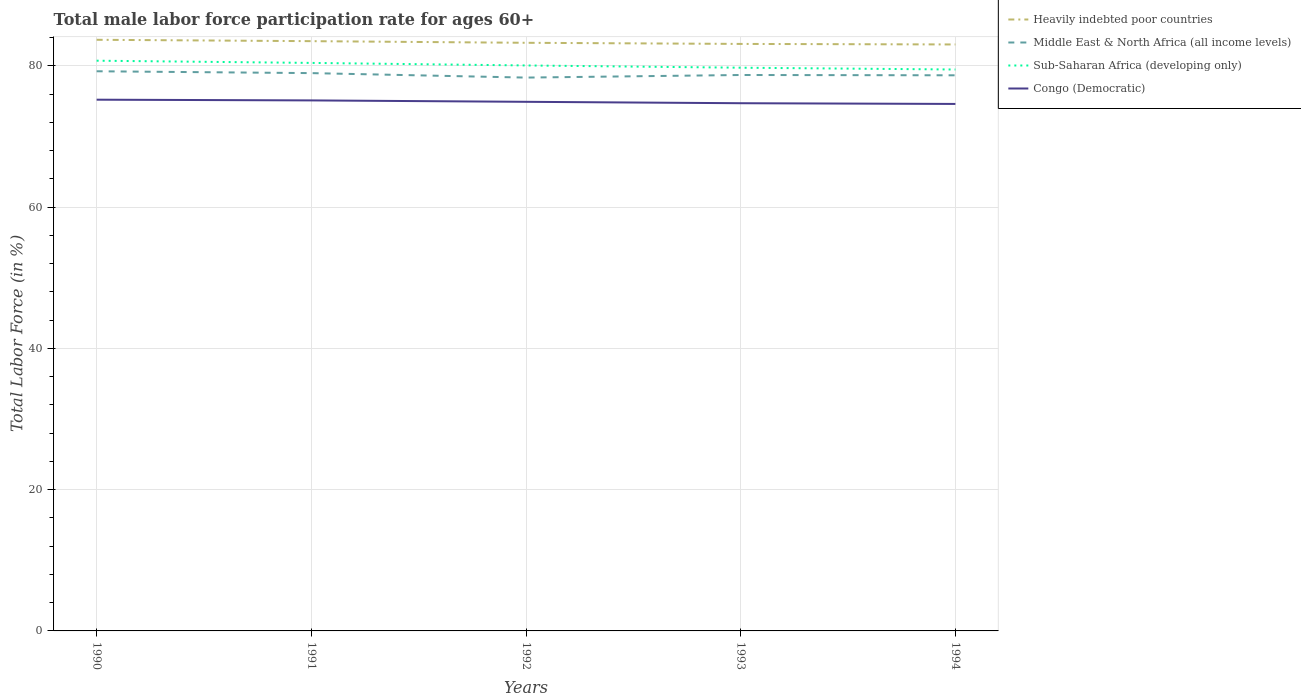How many different coloured lines are there?
Ensure brevity in your answer.  4. Does the line corresponding to Middle East & North Africa (all income levels) intersect with the line corresponding to Heavily indebted poor countries?
Your answer should be compact. No. Across all years, what is the maximum male labor force participation rate in Middle East & North Africa (all income levels)?
Offer a terse response. 78.33. In which year was the male labor force participation rate in Sub-Saharan Africa (developing only) maximum?
Offer a very short reply. 1994. What is the total male labor force participation rate in Congo (Democratic) in the graph?
Ensure brevity in your answer.  0.2. What is the difference between the highest and the second highest male labor force participation rate in Heavily indebted poor countries?
Keep it short and to the point. 0.66. What is the difference between the highest and the lowest male labor force participation rate in Heavily indebted poor countries?
Ensure brevity in your answer.  2. Is the male labor force participation rate in Middle East & North Africa (all income levels) strictly greater than the male labor force participation rate in Congo (Democratic) over the years?
Your response must be concise. No. Are the values on the major ticks of Y-axis written in scientific E-notation?
Keep it short and to the point. No. How are the legend labels stacked?
Provide a succinct answer. Vertical. What is the title of the graph?
Provide a succinct answer. Total male labor force participation rate for ages 60+. Does "Cabo Verde" appear as one of the legend labels in the graph?
Provide a short and direct response. No. What is the label or title of the X-axis?
Give a very brief answer. Years. What is the Total Labor Force (in %) in Heavily indebted poor countries in 1990?
Give a very brief answer. 83.68. What is the Total Labor Force (in %) of Middle East & North Africa (all income levels) in 1990?
Keep it short and to the point. 79.22. What is the Total Labor Force (in %) in Sub-Saharan Africa (developing only) in 1990?
Provide a succinct answer. 80.72. What is the Total Labor Force (in %) in Congo (Democratic) in 1990?
Your response must be concise. 75.2. What is the Total Labor Force (in %) of Heavily indebted poor countries in 1991?
Provide a short and direct response. 83.49. What is the Total Labor Force (in %) in Middle East & North Africa (all income levels) in 1991?
Ensure brevity in your answer.  78.96. What is the Total Labor Force (in %) of Sub-Saharan Africa (developing only) in 1991?
Your answer should be compact. 80.41. What is the Total Labor Force (in %) of Congo (Democratic) in 1991?
Provide a succinct answer. 75.1. What is the Total Labor Force (in %) in Heavily indebted poor countries in 1992?
Your answer should be very brief. 83.25. What is the Total Labor Force (in %) in Middle East & North Africa (all income levels) in 1992?
Offer a very short reply. 78.33. What is the Total Labor Force (in %) of Sub-Saharan Africa (developing only) in 1992?
Your answer should be compact. 80.05. What is the Total Labor Force (in %) in Congo (Democratic) in 1992?
Offer a very short reply. 74.9. What is the Total Labor Force (in %) in Heavily indebted poor countries in 1993?
Your answer should be very brief. 83.09. What is the Total Labor Force (in %) in Middle East & North Africa (all income levels) in 1993?
Your response must be concise. 78.7. What is the Total Labor Force (in %) in Sub-Saharan Africa (developing only) in 1993?
Keep it short and to the point. 79.73. What is the Total Labor Force (in %) in Congo (Democratic) in 1993?
Offer a terse response. 74.7. What is the Total Labor Force (in %) in Heavily indebted poor countries in 1994?
Offer a terse response. 83.02. What is the Total Labor Force (in %) of Middle East & North Africa (all income levels) in 1994?
Your response must be concise. 78.65. What is the Total Labor Force (in %) in Sub-Saharan Africa (developing only) in 1994?
Offer a very short reply. 79.47. What is the Total Labor Force (in %) of Congo (Democratic) in 1994?
Provide a short and direct response. 74.6. Across all years, what is the maximum Total Labor Force (in %) of Heavily indebted poor countries?
Ensure brevity in your answer.  83.68. Across all years, what is the maximum Total Labor Force (in %) of Middle East & North Africa (all income levels)?
Provide a succinct answer. 79.22. Across all years, what is the maximum Total Labor Force (in %) of Sub-Saharan Africa (developing only)?
Offer a terse response. 80.72. Across all years, what is the maximum Total Labor Force (in %) of Congo (Democratic)?
Your answer should be compact. 75.2. Across all years, what is the minimum Total Labor Force (in %) in Heavily indebted poor countries?
Provide a succinct answer. 83.02. Across all years, what is the minimum Total Labor Force (in %) in Middle East & North Africa (all income levels)?
Your response must be concise. 78.33. Across all years, what is the minimum Total Labor Force (in %) in Sub-Saharan Africa (developing only)?
Offer a terse response. 79.47. Across all years, what is the minimum Total Labor Force (in %) of Congo (Democratic)?
Your response must be concise. 74.6. What is the total Total Labor Force (in %) in Heavily indebted poor countries in the graph?
Your response must be concise. 416.53. What is the total Total Labor Force (in %) in Middle East & North Africa (all income levels) in the graph?
Give a very brief answer. 393.87. What is the total Total Labor Force (in %) in Sub-Saharan Africa (developing only) in the graph?
Offer a very short reply. 400.37. What is the total Total Labor Force (in %) in Congo (Democratic) in the graph?
Provide a succinct answer. 374.5. What is the difference between the Total Labor Force (in %) of Heavily indebted poor countries in 1990 and that in 1991?
Give a very brief answer. 0.19. What is the difference between the Total Labor Force (in %) of Middle East & North Africa (all income levels) in 1990 and that in 1991?
Keep it short and to the point. 0.26. What is the difference between the Total Labor Force (in %) of Sub-Saharan Africa (developing only) in 1990 and that in 1991?
Provide a short and direct response. 0.31. What is the difference between the Total Labor Force (in %) in Congo (Democratic) in 1990 and that in 1991?
Provide a short and direct response. 0.1. What is the difference between the Total Labor Force (in %) of Heavily indebted poor countries in 1990 and that in 1992?
Offer a very short reply. 0.43. What is the difference between the Total Labor Force (in %) of Middle East & North Africa (all income levels) in 1990 and that in 1992?
Provide a succinct answer. 0.89. What is the difference between the Total Labor Force (in %) in Sub-Saharan Africa (developing only) in 1990 and that in 1992?
Keep it short and to the point. 0.67. What is the difference between the Total Labor Force (in %) in Congo (Democratic) in 1990 and that in 1992?
Keep it short and to the point. 0.3. What is the difference between the Total Labor Force (in %) in Heavily indebted poor countries in 1990 and that in 1993?
Your answer should be very brief. 0.59. What is the difference between the Total Labor Force (in %) of Middle East & North Africa (all income levels) in 1990 and that in 1993?
Offer a very short reply. 0.53. What is the difference between the Total Labor Force (in %) in Sub-Saharan Africa (developing only) in 1990 and that in 1993?
Offer a very short reply. 0.99. What is the difference between the Total Labor Force (in %) in Congo (Democratic) in 1990 and that in 1993?
Your response must be concise. 0.5. What is the difference between the Total Labor Force (in %) of Heavily indebted poor countries in 1990 and that in 1994?
Your response must be concise. 0.66. What is the difference between the Total Labor Force (in %) of Middle East & North Africa (all income levels) in 1990 and that in 1994?
Make the answer very short. 0.57. What is the difference between the Total Labor Force (in %) in Sub-Saharan Africa (developing only) in 1990 and that in 1994?
Ensure brevity in your answer.  1.25. What is the difference between the Total Labor Force (in %) of Congo (Democratic) in 1990 and that in 1994?
Make the answer very short. 0.6. What is the difference between the Total Labor Force (in %) in Heavily indebted poor countries in 1991 and that in 1992?
Your answer should be very brief. 0.23. What is the difference between the Total Labor Force (in %) of Middle East & North Africa (all income levels) in 1991 and that in 1992?
Your answer should be compact. 0.63. What is the difference between the Total Labor Force (in %) in Sub-Saharan Africa (developing only) in 1991 and that in 1992?
Provide a short and direct response. 0.36. What is the difference between the Total Labor Force (in %) in Congo (Democratic) in 1991 and that in 1992?
Keep it short and to the point. 0.2. What is the difference between the Total Labor Force (in %) in Heavily indebted poor countries in 1991 and that in 1993?
Provide a succinct answer. 0.39. What is the difference between the Total Labor Force (in %) in Middle East & North Africa (all income levels) in 1991 and that in 1993?
Provide a succinct answer. 0.27. What is the difference between the Total Labor Force (in %) in Sub-Saharan Africa (developing only) in 1991 and that in 1993?
Keep it short and to the point. 0.68. What is the difference between the Total Labor Force (in %) of Congo (Democratic) in 1991 and that in 1993?
Ensure brevity in your answer.  0.4. What is the difference between the Total Labor Force (in %) of Heavily indebted poor countries in 1991 and that in 1994?
Make the answer very short. 0.47. What is the difference between the Total Labor Force (in %) of Middle East & North Africa (all income levels) in 1991 and that in 1994?
Ensure brevity in your answer.  0.31. What is the difference between the Total Labor Force (in %) of Sub-Saharan Africa (developing only) in 1991 and that in 1994?
Your response must be concise. 0.93. What is the difference between the Total Labor Force (in %) of Heavily indebted poor countries in 1992 and that in 1993?
Keep it short and to the point. 0.16. What is the difference between the Total Labor Force (in %) in Middle East & North Africa (all income levels) in 1992 and that in 1993?
Your response must be concise. -0.37. What is the difference between the Total Labor Force (in %) in Sub-Saharan Africa (developing only) in 1992 and that in 1993?
Your answer should be compact. 0.32. What is the difference between the Total Labor Force (in %) of Heavily indebted poor countries in 1992 and that in 1994?
Your answer should be compact. 0.24. What is the difference between the Total Labor Force (in %) of Middle East & North Africa (all income levels) in 1992 and that in 1994?
Make the answer very short. -0.32. What is the difference between the Total Labor Force (in %) of Sub-Saharan Africa (developing only) in 1992 and that in 1994?
Offer a very short reply. 0.58. What is the difference between the Total Labor Force (in %) of Congo (Democratic) in 1992 and that in 1994?
Ensure brevity in your answer.  0.3. What is the difference between the Total Labor Force (in %) in Heavily indebted poor countries in 1993 and that in 1994?
Your response must be concise. 0.08. What is the difference between the Total Labor Force (in %) in Middle East & North Africa (all income levels) in 1993 and that in 1994?
Offer a terse response. 0.04. What is the difference between the Total Labor Force (in %) in Sub-Saharan Africa (developing only) in 1993 and that in 1994?
Keep it short and to the point. 0.26. What is the difference between the Total Labor Force (in %) of Heavily indebted poor countries in 1990 and the Total Labor Force (in %) of Middle East & North Africa (all income levels) in 1991?
Keep it short and to the point. 4.72. What is the difference between the Total Labor Force (in %) in Heavily indebted poor countries in 1990 and the Total Labor Force (in %) in Sub-Saharan Africa (developing only) in 1991?
Offer a terse response. 3.27. What is the difference between the Total Labor Force (in %) in Heavily indebted poor countries in 1990 and the Total Labor Force (in %) in Congo (Democratic) in 1991?
Give a very brief answer. 8.58. What is the difference between the Total Labor Force (in %) in Middle East & North Africa (all income levels) in 1990 and the Total Labor Force (in %) in Sub-Saharan Africa (developing only) in 1991?
Give a very brief answer. -1.18. What is the difference between the Total Labor Force (in %) in Middle East & North Africa (all income levels) in 1990 and the Total Labor Force (in %) in Congo (Democratic) in 1991?
Offer a very short reply. 4.12. What is the difference between the Total Labor Force (in %) in Sub-Saharan Africa (developing only) in 1990 and the Total Labor Force (in %) in Congo (Democratic) in 1991?
Offer a terse response. 5.62. What is the difference between the Total Labor Force (in %) of Heavily indebted poor countries in 1990 and the Total Labor Force (in %) of Middle East & North Africa (all income levels) in 1992?
Your answer should be compact. 5.35. What is the difference between the Total Labor Force (in %) in Heavily indebted poor countries in 1990 and the Total Labor Force (in %) in Sub-Saharan Africa (developing only) in 1992?
Provide a short and direct response. 3.63. What is the difference between the Total Labor Force (in %) in Heavily indebted poor countries in 1990 and the Total Labor Force (in %) in Congo (Democratic) in 1992?
Your answer should be compact. 8.78. What is the difference between the Total Labor Force (in %) of Middle East & North Africa (all income levels) in 1990 and the Total Labor Force (in %) of Sub-Saharan Africa (developing only) in 1992?
Ensure brevity in your answer.  -0.82. What is the difference between the Total Labor Force (in %) in Middle East & North Africa (all income levels) in 1990 and the Total Labor Force (in %) in Congo (Democratic) in 1992?
Provide a short and direct response. 4.32. What is the difference between the Total Labor Force (in %) in Sub-Saharan Africa (developing only) in 1990 and the Total Labor Force (in %) in Congo (Democratic) in 1992?
Provide a succinct answer. 5.82. What is the difference between the Total Labor Force (in %) of Heavily indebted poor countries in 1990 and the Total Labor Force (in %) of Middle East & North Africa (all income levels) in 1993?
Give a very brief answer. 4.98. What is the difference between the Total Labor Force (in %) in Heavily indebted poor countries in 1990 and the Total Labor Force (in %) in Sub-Saharan Africa (developing only) in 1993?
Offer a terse response. 3.95. What is the difference between the Total Labor Force (in %) of Heavily indebted poor countries in 1990 and the Total Labor Force (in %) of Congo (Democratic) in 1993?
Provide a short and direct response. 8.98. What is the difference between the Total Labor Force (in %) in Middle East & North Africa (all income levels) in 1990 and the Total Labor Force (in %) in Sub-Saharan Africa (developing only) in 1993?
Your answer should be very brief. -0.5. What is the difference between the Total Labor Force (in %) of Middle East & North Africa (all income levels) in 1990 and the Total Labor Force (in %) of Congo (Democratic) in 1993?
Your response must be concise. 4.52. What is the difference between the Total Labor Force (in %) in Sub-Saharan Africa (developing only) in 1990 and the Total Labor Force (in %) in Congo (Democratic) in 1993?
Ensure brevity in your answer.  6.02. What is the difference between the Total Labor Force (in %) of Heavily indebted poor countries in 1990 and the Total Labor Force (in %) of Middle East & North Africa (all income levels) in 1994?
Offer a very short reply. 5.03. What is the difference between the Total Labor Force (in %) in Heavily indebted poor countries in 1990 and the Total Labor Force (in %) in Sub-Saharan Africa (developing only) in 1994?
Give a very brief answer. 4.21. What is the difference between the Total Labor Force (in %) in Heavily indebted poor countries in 1990 and the Total Labor Force (in %) in Congo (Democratic) in 1994?
Keep it short and to the point. 9.08. What is the difference between the Total Labor Force (in %) of Middle East & North Africa (all income levels) in 1990 and the Total Labor Force (in %) of Sub-Saharan Africa (developing only) in 1994?
Offer a terse response. -0.25. What is the difference between the Total Labor Force (in %) of Middle East & North Africa (all income levels) in 1990 and the Total Labor Force (in %) of Congo (Democratic) in 1994?
Your response must be concise. 4.62. What is the difference between the Total Labor Force (in %) in Sub-Saharan Africa (developing only) in 1990 and the Total Labor Force (in %) in Congo (Democratic) in 1994?
Provide a short and direct response. 6.12. What is the difference between the Total Labor Force (in %) of Heavily indebted poor countries in 1991 and the Total Labor Force (in %) of Middle East & North Africa (all income levels) in 1992?
Give a very brief answer. 5.16. What is the difference between the Total Labor Force (in %) in Heavily indebted poor countries in 1991 and the Total Labor Force (in %) in Sub-Saharan Africa (developing only) in 1992?
Give a very brief answer. 3.44. What is the difference between the Total Labor Force (in %) in Heavily indebted poor countries in 1991 and the Total Labor Force (in %) in Congo (Democratic) in 1992?
Offer a very short reply. 8.59. What is the difference between the Total Labor Force (in %) in Middle East & North Africa (all income levels) in 1991 and the Total Labor Force (in %) in Sub-Saharan Africa (developing only) in 1992?
Provide a succinct answer. -1.08. What is the difference between the Total Labor Force (in %) of Middle East & North Africa (all income levels) in 1991 and the Total Labor Force (in %) of Congo (Democratic) in 1992?
Your response must be concise. 4.06. What is the difference between the Total Labor Force (in %) of Sub-Saharan Africa (developing only) in 1991 and the Total Labor Force (in %) of Congo (Democratic) in 1992?
Your answer should be very brief. 5.51. What is the difference between the Total Labor Force (in %) of Heavily indebted poor countries in 1991 and the Total Labor Force (in %) of Middle East & North Africa (all income levels) in 1993?
Give a very brief answer. 4.79. What is the difference between the Total Labor Force (in %) in Heavily indebted poor countries in 1991 and the Total Labor Force (in %) in Sub-Saharan Africa (developing only) in 1993?
Offer a very short reply. 3.76. What is the difference between the Total Labor Force (in %) in Heavily indebted poor countries in 1991 and the Total Labor Force (in %) in Congo (Democratic) in 1993?
Offer a terse response. 8.79. What is the difference between the Total Labor Force (in %) of Middle East & North Africa (all income levels) in 1991 and the Total Labor Force (in %) of Sub-Saharan Africa (developing only) in 1993?
Your answer should be compact. -0.76. What is the difference between the Total Labor Force (in %) in Middle East & North Africa (all income levels) in 1991 and the Total Labor Force (in %) in Congo (Democratic) in 1993?
Keep it short and to the point. 4.26. What is the difference between the Total Labor Force (in %) of Sub-Saharan Africa (developing only) in 1991 and the Total Labor Force (in %) of Congo (Democratic) in 1993?
Provide a succinct answer. 5.71. What is the difference between the Total Labor Force (in %) of Heavily indebted poor countries in 1991 and the Total Labor Force (in %) of Middle East & North Africa (all income levels) in 1994?
Provide a succinct answer. 4.83. What is the difference between the Total Labor Force (in %) of Heavily indebted poor countries in 1991 and the Total Labor Force (in %) of Sub-Saharan Africa (developing only) in 1994?
Ensure brevity in your answer.  4.01. What is the difference between the Total Labor Force (in %) of Heavily indebted poor countries in 1991 and the Total Labor Force (in %) of Congo (Democratic) in 1994?
Keep it short and to the point. 8.89. What is the difference between the Total Labor Force (in %) of Middle East & North Africa (all income levels) in 1991 and the Total Labor Force (in %) of Sub-Saharan Africa (developing only) in 1994?
Your response must be concise. -0.51. What is the difference between the Total Labor Force (in %) in Middle East & North Africa (all income levels) in 1991 and the Total Labor Force (in %) in Congo (Democratic) in 1994?
Make the answer very short. 4.36. What is the difference between the Total Labor Force (in %) in Sub-Saharan Africa (developing only) in 1991 and the Total Labor Force (in %) in Congo (Democratic) in 1994?
Keep it short and to the point. 5.81. What is the difference between the Total Labor Force (in %) of Heavily indebted poor countries in 1992 and the Total Labor Force (in %) of Middle East & North Africa (all income levels) in 1993?
Your answer should be compact. 4.56. What is the difference between the Total Labor Force (in %) in Heavily indebted poor countries in 1992 and the Total Labor Force (in %) in Sub-Saharan Africa (developing only) in 1993?
Keep it short and to the point. 3.53. What is the difference between the Total Labor Force (in %) of Heavily indebted poor countries in 1992 and the Total Labor Force (in %) of Congo (Democratic) in 1993?
Your response must be concise. 8.55. What is the difference between the Total Labor Force (in %) in Middle East & North Africa (all income levels) in 1992 and the Total Labor Force (in %) in Sub-Saharan Africa (developing only) in 1993?
Offer a very short reply. -1.4. What is the difference between the Total Labor Force (in %) in Middle East & North Africa (all income levels) in 1992 and the Total Labor Force (in %) in Congo (Democratic) in 1993?
Your answer should be compact. 3.63. What is the difference between the Total Labor Force (in %) of Sub-Saharan Africa (developing only) in 1992 and the Total Labor Force (in %) of Congo (Democratic) in 1993?
Keep it short and to the point. 5.35. What is the difference between the Total Labor Force (in %) of Heavily indebted poor countries in 1992 and the Total Labor Force (in %) of Middle East & North Africa (all income levels) in 1994?
Keep it short and to the point. 4.6. What is the difference between the Total Labor Force (in %) in Heavily indebted poor countries in 1992 and the Total Labor Force (in %) in Sub-Saharan Africa (developing only) in 1994?
Give a very brief answer. 3.78. What is the difference between the Total Labor Force (in %) in Heavily indebted poor countries in 1992 and the Total Labor Force (in %) in Congo (Democratic) in 1994?
Offer a very short reply. 8.65. What is the difference between the Total Labor Force (in %) in Middle East & North Africa (all income levels) in 1992 and the Total Labor Force (in %) in Sub-Saharan Africa (developing only) in 1994?
Keep it short and to the point. -1.14. What is the difference between the Total Labor Force (in %) of Middle East & North Africa (all income levels) in 1992 and the Total Labor Force (in %) of Congo (Democratic) in 1994?
Keep it short and to the point. 3.73. What is the difference between the Total Labor Force (in %) in Sub-Saharan Africa (developing only) in 1992 and the Total Labor Force (in %) in Congo (Democratic) in 1994?
Give a very brief answer. 5.45. What is the difference between the Total Labor Force (in %) in Heavily indebted poor countries in 1993 and the Total Labor Force (in %) in Middle East & North Africa (all income levels) in 1994?
Offer a terse response. 4.44. What is the difference between the Total Labor Force (in %) in Heavily indebted poor countries in 1993 and the Total Labor Force (in %) in Sub-Saharan Africa (developing only) in 1994?
Offer a very short reply. 3.62. What is the difference between the Total Labor Force (in %) in Heavily indebted poor countries in 1993 and the Total Labor Force (in %) in Congo (Democratic) in 1994?
Give a very brief answer. 8.49. What is the difference between the Total Labor Force (in %) in Middle East & North Africa (all income levels) in 1993 and the Total Labor Force (in %) in Sub-Saharan Africa (developing only) in 1994?
Your response must be concise. -0.78. What is the difference between the Total Labor Force (in %) of Middle East & North Africa (all income levels) in 1993 and the Total Labor Force (in %) of Congo (Democratic) in 1994?
Your answer should be very brief. 4.1. What is the difference between the Total Labor Force (in %) of Sub-Saharan Africa (developing only) in 1993 and the Total Labor Force (in %) of Congo (Democratic) in 1994?
Give a very brief answer. 5.13. What is the average Total Labor Force (in %) in Heavily indebted poor countries per year?
Ensure brevity in your answer.  83.31. What is the average Total Labor Force (in %) of Middle East & North Africa (all income levels) per year?
Provide a short and direct response. 78.77. What is the average Total Labor Force (in %) of Sub-Saharan Africa (developing only) per year?
Offer a terse response. 80.07. What is the average Total Labor Force (in %) of Congo (Democratic) per year?
Keep it short and to the point. 74.9. In the year 1990, what is the difference between the Total Labor Force (in %) in Heavily indebted poor countries and Total Labor Force (in %) in Middle East & North Africa (all income levels)?
Ensure brevity in your answer.  4.46. In the year 1990, what is the difference between the Total Labor Force (in %) in Heavily indebted poor countries and Total Labor Force (in %) in Sub-Saharan Africa (developing only)?
Offer a very short reply. 2.96. In the year 1990, what is the difference between the Total Labor Force (in %) of Heavily indebted poor countries and Total Labor Force (in %) of Congo (Democratic)?
Offer a very short reply. 8.48. In the year 1990, what is the difference between the Total Labor Force (in %) of Middle East & North Africa (all income levels) and Total Labor Force (in %) of Sub-Saharan Africa (developing only)?
Offer a terse response. -1.5. In the year 1990, what is the difference between the Total Labor Force (in %) of Middle East & North Africa (all income levels) and Total Labor Force (in %) of Congo (Democratic)?
Make the answer very short. 4.02. In the year 1990, what is the difference between the Total Labor Force (in %) of Sub-Saharan Africa (developing only) and Total Labor Force (in %) of Congo (Democratic)?
Your answer should be very brief. 5.52. In the year 1991, what is the difference between the Total Labor Force (in %) in Heavily indebted poor countries and Total Labor Force (in %) in Middle East & North Africa (all income levels)?
Give a very brief answer. 4.52. In the year 1991, what is the difference between the Total Labor Force (in %) in Heavily indebted poor countries and Total Labor Force (in %) in Sub-Saharan Africa (developing only)?
Offer a terse response. 3.08. In the year 1991, what is the difference between the Total Labor Force (in %) in Heavily indebted poor countries and Total Labor Force (in %) in Congo (Democratic)?
Offer a very short reply. 8.39. In the year 1991, what is the difference between the Total Labor Force (in %) of Middle East & North Africa (all income levels) and Total Labor Force (in %) of Sub-Saharan Africa (developing only)?
Offer a terse response. -1.44. In the year 1991, what is the difference between the Total Labor Force (in %) in Middle East & North Africa (all income levels) and Total Labor Force (in %) in Congo (Democratic)?
Ensure brevity in your answer.  3.86. In the year 1991, what is the difference between the Total Labor Force (in %) in Sub-Saharan Africa (developing only) and Total Labor Force (in %) in Congo (Democratic)?
Your answer should be compact. 5.31. In the year 1992, what is the difference between the Total Labor Force (in %) in Heavily indebted poor countries and Total Labor Force (in %) in Middle East & North Africa (all income levels)?
Ensure brevity in your answer.  4.92. In the year 1992, what is the difference between the Total Labor Force (in %) of Heavily indebted poor countries and Total Labor Force (in %) of Sub-Saharan Africa (developing only)?
Your answer should be very brief. 3.21. In the year 1992, what is the difference between the Total Labor Force (in %) in Heavily indebted poor countries and Total Labor Force (in %) in Congo (Democratic)?
Offer a terse response. 8.35. In the year 1992, what is the difference between the Total Labor Force (in %) of Middle East & North Africa (all income levels) and Total Labor Force (in %) of Sub-Saharan Africa (developing only)?
Ensure brevity in your answer.  -1.72. In the year 1992, what is the difference between the Total Labor Force (in %) of Middle East & North Africa (all income levels) and Total Labor Force (in %) of Congo (Democratic)?
Offer a terse response. 3.43. In the year 1992, what is the difference between the Total Labor Force (in %) in Sub-Saharan Africa (developing only) and Total Labor Force (in %) in Congo (Democratic)?
Keep it short and to the point. 5.15. In the year 1993, what is the difference between the Total Labor Force (in %) in Heavily indebted poor countries and Total Labor Force (in %) in Middle East & North Africa (all income levels)?
Make the answer very short. 4.4. In the year 1993, what is the difference between the Total Labor Force (in %) of Heavily indebted poor countries and Total Labor Force (in %) of Sub-Saharan Africa (developing only)?
Ensure brevity in your answer.  3.37. In the year 1993, what is the difference between the Total Labor Force (in %) of Heavily indebted poor countries and Total Labor Force (in %) of Congo (Democratic)?
Make the answer very short. 8.39. In the year 1993, what is the difference between the Total Labor Force (in %) in Middle East & North Africa (all income levels) and Total Labor Force (in %) in Sub-Saharan Africa (developing only)?
Your response must be concise. -1.03. In the year 1993, what is the difference between the Total Labor Force (in %) in Middle East & North Africa (all income levels) and Total Labor Force (in %) in Congo (Democratic)?
Your response must be concise. 4. In the year 1993, what is the difference between the Total Labor Force (in %) in Sub-Saharan Africa (developing only) and Total Labor Force (in %) in Congo (Democratic)?
Give a very brief answer. 5.03. In the year 1994, what is the difference between the Total Labor Force (in %) of Heavily indebted poor countries and Total Labor Force (in %) of Middle East & North Africa (all income levels)?
Provide a short and direct response. 4.37. In the year 1994, what is the difference between the Total Labor Force (in %) in Heavily indebted poor countries and Total Labor Force (in %) in Sub-Saharan Africa (developing only)?
Your answer should be very brief. 3.55. In the year 1994, what is the difference between the Total Labor Force (in %) of Heavily indebted poor countries and Total Labor Force (in %) of Congo (Democratic)?
Your answer should be very brief. 8.42. In the year 1994, what is the difference between the Total Labor Force (in %) of Middle East & North Africa (all income levels) and Total Labor Force (in %) of Sub-Saharan Africa (developing only)?
Offer a very short reply. -0.82. In the year 1994, what is the difference between the Total Labor Force (in %) in Middle East & North Africa (all income levels) and Total Labor Force (in %) in Congo (Democratic)?
Provide a succinct answer. 4.05. In the year 1994, what is the difference between the Total Labor Force (in %) in Sub-Saharan Africa (developing only) and Total Labor Force (in %) in Congo (Democratic)?
Ensure brevity in your answer.  4.87. What is the ratio of the Total Labor Force (in %) of Middle East & North Africa (all income levels) in 1990 to that in 1991?
Your response must be concise. 1. What is the ratio of the Total Labor Force (in %) in Congo (Democratic) in 1990 to that in 1991?
Your answer should be very brief. 1. What is the ratio of the Total Labor Force (in %) in Heavily indebted poor countries in 1990 to that in 1992?
Your answer should be compact. 1.01. What is the ratio of the Total Labor Force (in %) in Middle East & North Africa (all income levels) in 1990 to that in 1992?
Make the answer very short. 1.01. What is the ratio of the Total Labor Force (in %) of Sub-Saharan Africa (developing only) in 1990 to that in 1992?
Ensure brevity in your answer.  1.01. What is the ratio of the Total Labor Force (in %) of Congo (Democratic) in 1990 to that in 1992?
Make the answer very short. 1. What is the ratio of the Total Labor Force (in %) of Heavily indebted poor countries in 1990 to that in 1993?
Make the answer very short. 1.01. What is the ratio of the Total Labor Force (in %) of Middle East & North Africa (all income levels) in 1990 to that in 1993?
Offer a terse response. 1.01. What is the ratio of the Total Labor Force (in %) in Sub-Saharan Africa (developing only) in 1990 to that in 1993?
Offer a very short reply. 1.01. What is the ratio of the Total Labor Force (in %) in Heavily indebted poor countries in 1990 to that in 1994?
Your answer should be very brief. 1.01. What is the ratio of the Total Labor Force (in %) of Middle East & North Africa (all income levels) in 1990 to that in 1994?
Your answer should be compact. 1.01. What is the ratio of the Total Labor Force (in %) of Sub-Saharan Africa (developing only) in 1990 to that in 1994?
Your response must be concise. 1.02. What is the ratio of the Total Labor Force (in %) of Heavily indebted poor countries in 1991 to that in 1992?
Keep it short and to the point. 1. What is the ratio of the Total Labor Force (in %) of Middle East & North Africa (all income levels) in 1991 to that in 1992?
Your answer should be compact. 1.01. What is the ratio of the Total Labor Force (in %) of Sub-Saharan Africa (developing only) in 1991 to that in 1992?
Provide a succinct answer. 1. What is the ratio of the Total Labor Force (in %) in Congo (Democratic) in 1991 to that in 1992?
Offer a terse response. 1. What is the ratio of the Total Labor Force (in %) in Middle East & North Africa (all income levels) in 1991 to that in 1993?
Offer a very short reply. 1. What is the ratio of the Total Labor Force (in %) of Sub-Saharan Africa (developing only) in 1991 to that in 1993?
Your answer should be very brief. 1.01. What is the ratio of the Total Labor Force (in %) in Congo (Democratic) in 1991 to that in 1993?
Your response must be concise. 1.01. What is the ratio of the Total Labor Force (in %) in Heavily indebted poor countries in 1991 to that in 1994?
Your answer should be compact. 1.01. What is the ratio of the Total Labor Force (in %) in Middle East & North Africa (all income levels) in 1991 to that in 1994?
Provide a succinct answer. 1. What is the ratio of the Total Labor Force (in %) of Sub-Saharan Africa (developing only) in 1991 to that in 1994?
Your response must be concise. 1.01. What is the ratio of the Total Labor Force (in %) of Congo (Democratic) in 1991 to that in 1994?
Give a very brief answer. 1.01. What is the ratio of the Total Labor Force (in %) of Heavily indebted poor countries in 1992 to that in 1993?
Provide a succinct answer. 1. What is the ratio of the Total Labor Force (in %) in Congo (Democratic) in 1992 to that in 1993?
Your response must be concise. 1. What is the ratio of the Total Labor Force (in %) in Sub-Saharan Africa (developing only) in 1992 to that in 1994?
Give a very brief answer. 1.01. What is the ratio of the Total Labor Force (in %) of Congo (Democratic) in 1992 to that in 1994?
Your answer should be compact. 1. What is the ratio of the Total Labor Force (in %) of Heavily indebted poor countries in 1993 to that in 1994?
Your response must be concise. 1. What is the ratio of the Total Labor Force (in %) in Middle East & North Africa (all income levels) in 1993 to that in 1994?
Provide a succinct answer. 1. What is the ratio of the Total Labor Force (in %) of Congo (Democratic) in 1993 to that in 1994?
Provide a succinct answer. 1. What is the difference between the highest and the second highest Total Labor Force (in %) of Heavily indebted poor countries?
Keep it short and to the point. 0.19. What is the difference between the highest and the second highest Total Labor Force (in %) of Middle East & North Africa (all income levels)?
Give a very brief answer. 0.26. What is the difference between the highest and the second highest Total Labor Force (in %) in Sub-Saharan Africa (developing only)?
Provide a succinct answer. 0.31. What is the difference between the highest and the second highest Total Labor Force (in %) of Congo (Democratic)?
Give a very brief answer. 0.1. What is the difference between the highest and the lowest Total Labor Force (in %) in Heavily indebted poor countries?
Make the answer very short. 0.66. What is the difference between the highest and the lowest Total Labor Force (in %) in Middle East & North Africa (all income levels)?
Provide a short and direct response. 0.89. What is the difference between the highest and the lowest Total Labor Force (in %) of Sub-Saharan Africa (developing only)?
Provide a short and direct response. 1.25. What is the difference between the highest and the lowest Total Labor Force (in %) in Congo (Democratic)?
Provide a short and direct response. 0.6. 